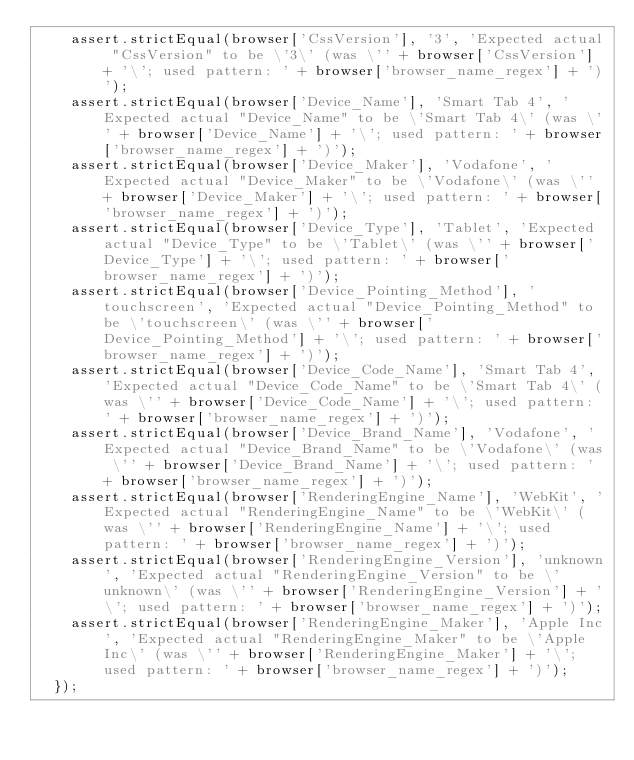Convert code to text. <code><loc_0><loc_0><loc_500><loc_500><_JavaScript_>    assert.strictEqual(browser['CssVersion'], '3', 'Expected actual "CssVersion" to be \'3\' (was \'' + browser['CssVersion'] + '\'; used pattern: ' + browser['browser_name_regex'] + ')');
    assert.strictEqual(browser['Device_Name'], 'Smart Tab 4', 'Expected actual "Device_Name" to be \'Smart Tab 4\' (was \'' + browser['Device_Name'] + '\'; used pattern: ' + browser['browser_name_regex'] + ')');
    assert.strictEqual(browser['Device_Maker'], 'Vodafone', 'Expected actual "Device_Maker" to be \'Vodafone\' (was \'' + browser['Device_Maker'] + '\'; used pattern: ' + browser['browser_name_regex'] + ')');
    assert.strictEqual(browser['Device_Type'], 'Tablet', 'Expected actual "Device_Type" to be \'Tablet\' (was \'' + browser['Device_Type'] + '\'; used pattern: ' + browser['browser_name_regex'] + ')');
    assert.strictEqual(browser['Device_Pointing_Method'], 'touchscreen', 'Expected actual "Device_Pointing_Method" to be \'touchscreen\' (was \'' + browser['Device_Pointing_Method'] + '\'; used pattern: ' + browser['browser_name_regex'] + ')');
    assert.strictEqual(browser['Device_Code_Name'], 'Smart Tab 4', 'Expected actual "Device_Code_Name" to be \'Smart Tab 4\' (was \'' + browser['Device_Code_Name'] + '\'; used pattern: ' + browser['browser_name_regex'] + ')');
    assert.strictEqual(browser['Device_Brand_Name'], 'Vodafone', 'Expected actual "Device_Brand_Name" to be \'Vodafone\' (was \'' + browser['Device_Brand_Name'] + '\'; used pattern: ' + browser['browser_name_regex'] + ')');
    assert.strictEqual(browser['RenderingEngine_Name'], 'WebKit', 'Expected actual "RenderingEngine_Name" to be \'WebKit\' (was \'' + browser['RenderingEngine_Name'] + '\'; used pattern: ' + browser['browser_name_regex'] + ')');
    assert.strictEqual(browser['RenderingEngine_Version'], 'unknown', 'Expected actual "RenderingEngine_Version" to be \'unknown\' (was \'' + browser['RenderingEngine_Version'] + '\'; used pattern: ' + browser['browser_name_regex'] + ')');
    assert.strictEqual(browser['RenderingEngine_Maker'], 'Apple Inc', 'Expected actual "RenderingEngine_Maker" to be \'Apple Inc\' (was \'' + browser['RenderingEngine_Maker'] + '\'; used pattern: ' + browser['browser_name_regex'] + ')');
  });</code> 